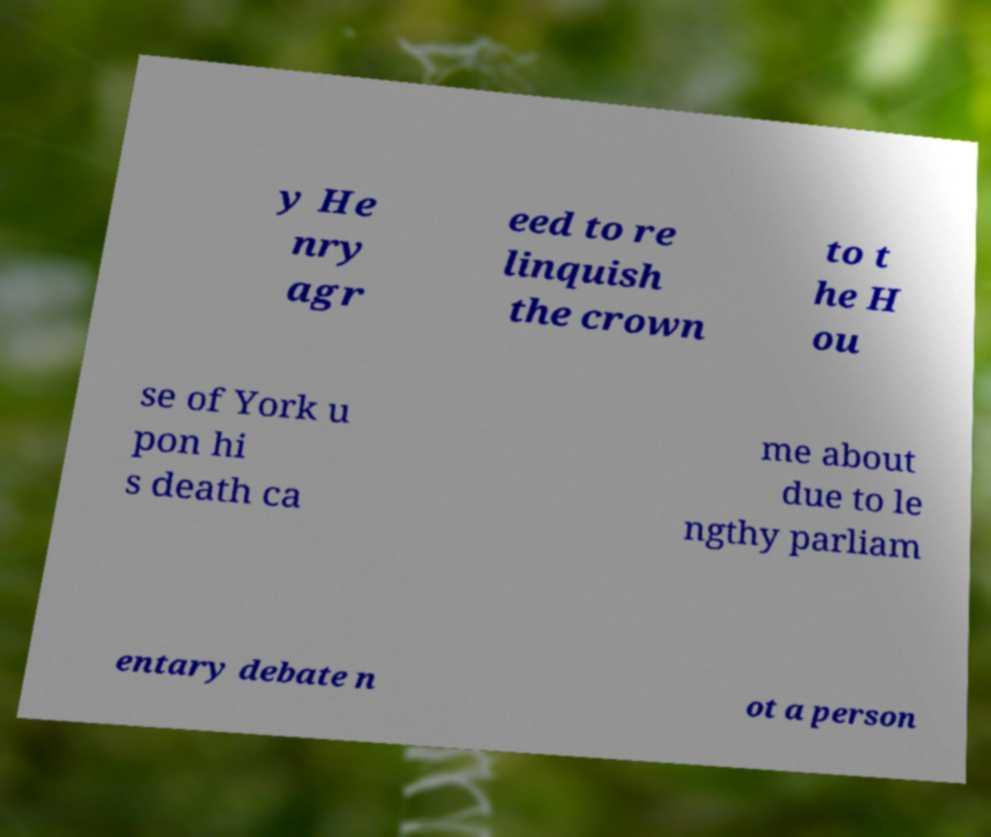Please identify and transcribe the text found in this image. y He nry agr eed to re linquish the crown to t he H ou se of York u pon hi s death ca me about due to le ngthy parliam entary debate n ot a person 